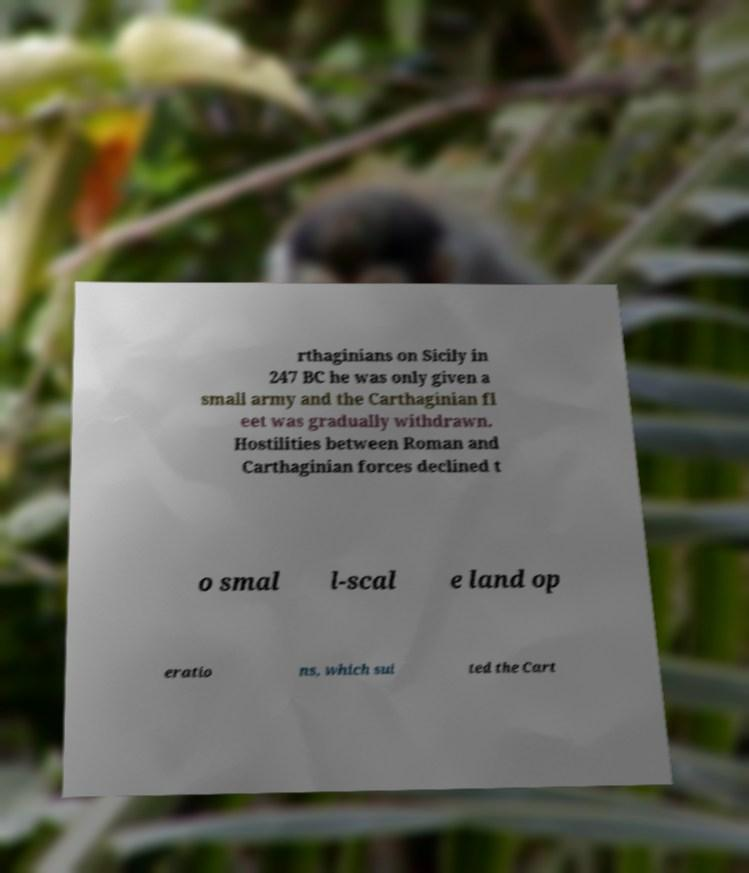Could you assist in decoding the text presented in this image and type it out clearly? rthaginians on Sicily in 247 BC he was only given a small army and the Carthaginian fl eet was gradually withdrawn. Hostilities between Roman and Carthaginian forces declined t o smal l-scal e land op eratio ns, which sui ted the Cart 